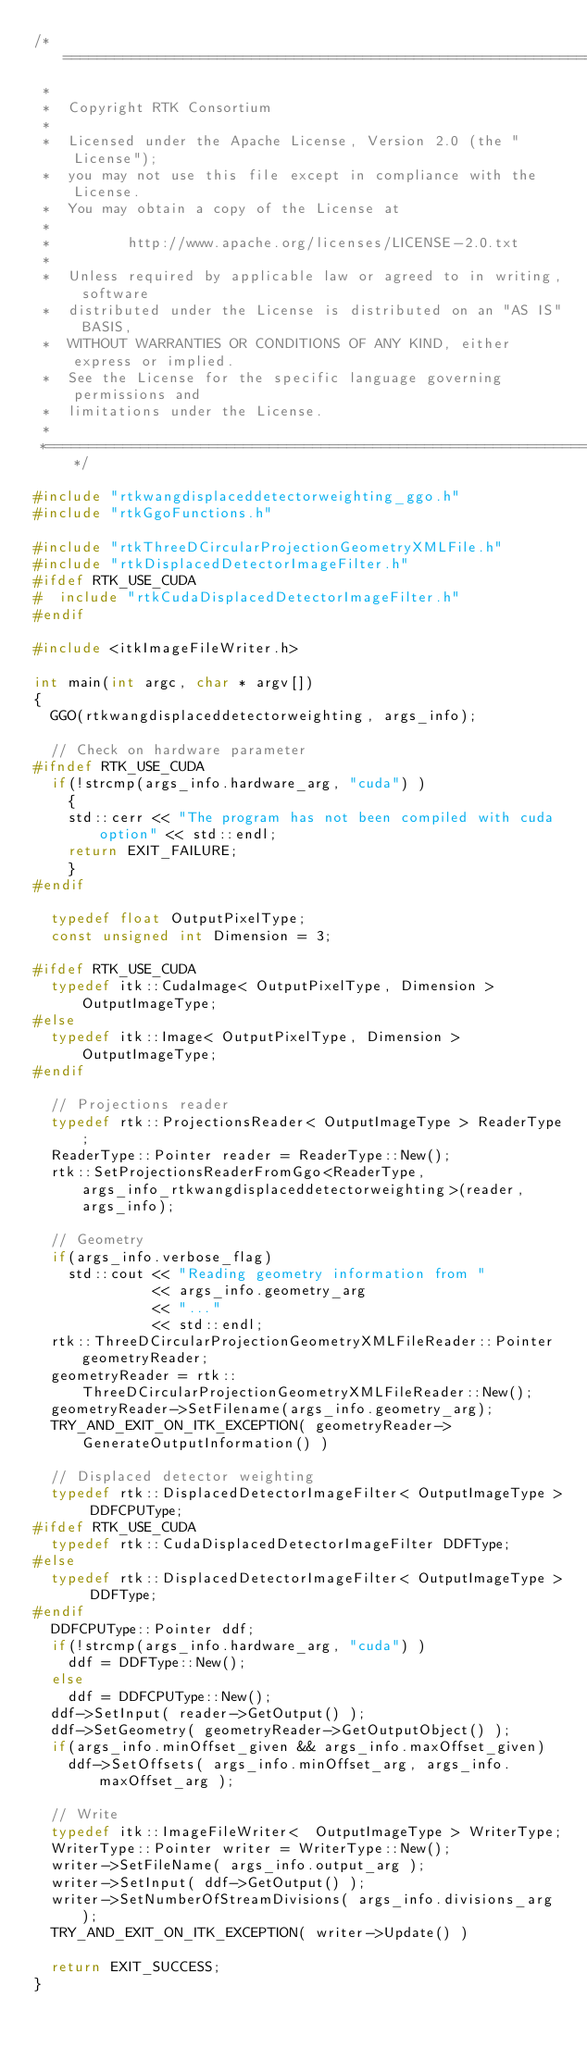<code> <loc_0><loc_0><loc_500><loc_500><_C++_>/*=========================================================================
 *
 *  Copyright RTK Consortium
 *
 *  Licensed under the Apache License, Version 2.0 (the "License");
 *  you may not use this file except in compliance with the License.
 *  You may obtain a copy of the License at
 *
 *         http://www.apache.org/licenses/LICENSE-2.0.txt
 *
 *  Unless required by applicable law or agreed to in writing, software
 *  distributed under the License is distributed on an "AS IS" BASIS,
 *  WITHOUT WARRANTIES OR CONDITIONS OF ANY KIND, either express or implied.
 *  See the License for the specific language governing permissions and
 *  limitations under the License.
 *
 *=========================================================================*/

#include "rtkwangdisplaceddetectorweighting_ggo.h"
#include "rtkGgoFunctions.h"

#include "rtkThreeDCircularProjectionGeometryXMLFile.h"
#include "rtkDisplacedDetectorImageFilter.h"
#ifdef RTK_USE_CUDA
#  include "rtkCudaDisplacedDetectorImageFilter.h"
#endif

#include <itkImageFileWriter.h>

int main(int argc, char * argv[])
{
  GGO(rtkwangdisplaceddetectorweighting, args_info);

  // Check on hardware parameter
#ifndef RTK_USE_CUDA
  if(!strcmp(args_info.hardware_arg, "cuda") )
    {
    std::cerr << "The program has not been compiled with cuda option" << std::endl;
    return EXIT_FAILURE;
    }
#endif

  typedef float OutputPixelType;
  const unsigned int Dimension = 3;

#ifdef RTK_USE_CUDA
  typedef itk::CudaImage< OutputPixelType, Dimension > OutputImageType;
#else
  typedef itk::Image< OutputPixelType, Dimension > OutputImageType;
#endif

  // Projections reader
  typedef rtk::ProjectionsReader< OutputImageType > ReaderType;
  ReaderType::Pointer reader = ReaderType::New();
  rtk::SetProjectionsReaderFromGgo<ReaderType, args_info_rtkwangdisplaceddetectorweighting>(reader, args_info);

  // Geometry
  if(args_info.verbose_flag)
    std::cout << "Reading geometry information from "
              << args_info.geometry_arg
              << "..."
              << std::endl;
  rtk::ThreeDCircularProjectionGeometryXMLFileReader::Pointer geometryReader;
  geometryReader = rtk::ThreeDCircularProjectionGeometryXMLFileReader::New();
  geometryReader->SetFilename(args_info.geometry_arg);
  TRY_AND_EXIT_ON_ITK_EXCEPTION( geometryReader->GenerateOutputInformation() )

  // Displaced detector weighting
  typedef rtk::DisplacedDetectorImageFilter< OutputImageType > DDFCPUType;
#ifdef RTK_USE_CUDA
  typedef rtk::CudaDisplacedDetectorImageFilter DDFType;
#else
  typedef rtk::DisplacedDetectorImageFilter< OutputImageType > DDFType;
#endif
  DDFCPUType::Pointer ddf;
  if(!strcmp(args_info.hardware_arg, "cuda") )
    ddf = DDFType::New();
  else
    ddf = DDFCPUType::New();
  ddf->SetInput( reader->GetOutput() );
  ddf->SetGeometry( geometryReader->GetOutputObject() );
  if(args_info.minOffset_given && args_info.maxOffset_given)
    ddf->SetOffsets( args_info.minOffset_arg, args_info.maxOffset_arg );

  // Write
  typedef itk::ImageFileWriter<  OutputImageType > WriterType;
  WriterType::Pointer writer = WriterType::New();
  writer->SetFileName( args_info.output_arg );
  writer->SetInput( ddf->GetOutput() );
  writer->SetNumberOfStreamDivisions( args_info.divisions_arg );
  TRY_AND_EXIT_ON_ITK_EXCEPTION( writer->Update() )

  return EXIT_SUCCESS;
}
</code> 